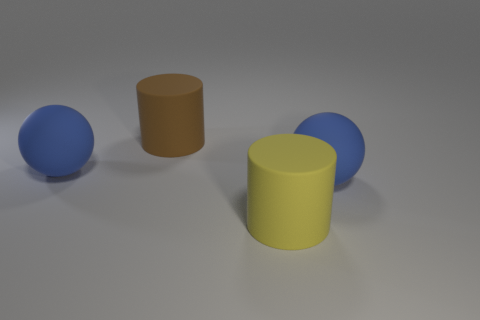How big is the blue object to the right of the blue matte thing that is behind the big blue rubber thing right of the brown matte cylinder?
Your answer should be compact. Large. Is there a brown thing?
Your answer should be very brief. Yes. What number of things are either matte cylinders behind the big yellow rubber thing or big balls behind the big yellow cylinder?
Ensure brevity in your answer.  3. How many big blue things are to the left of the large rubber cylinder that is behind the large yellow cylinder?
Provide a short and direct response. 1. There is another large cylinder that is the same material as the yellow cylinder; what color is it?
Your answer should be very brief. Brown. Is there a brown rubber sphere of the same size as the yellow cylinder?
Your answer should be very brief. No. There is a brown thing that is the same size as the yellow rubber cylinder; what shape is it?
Offer a terse response. Cylinder. Are there any other metallic objects of the same shape as the large brown thing?
Make the answer very short. No. Does the brown cylinder have the same material as the large cylinder that is in front of the brown cylinder?
Provide a short and direct response. Yes. How many other objects are there of the same material as the large brown cylinder?
Offer a very short reply. 3. 